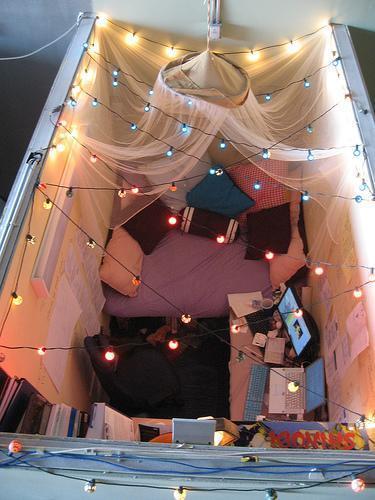How many beds are in the room?
Give a very brief answer. 1. 